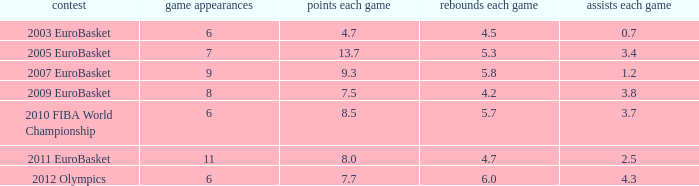How many assists per game in the tournament 2010 fiba world championship? 3.7. 